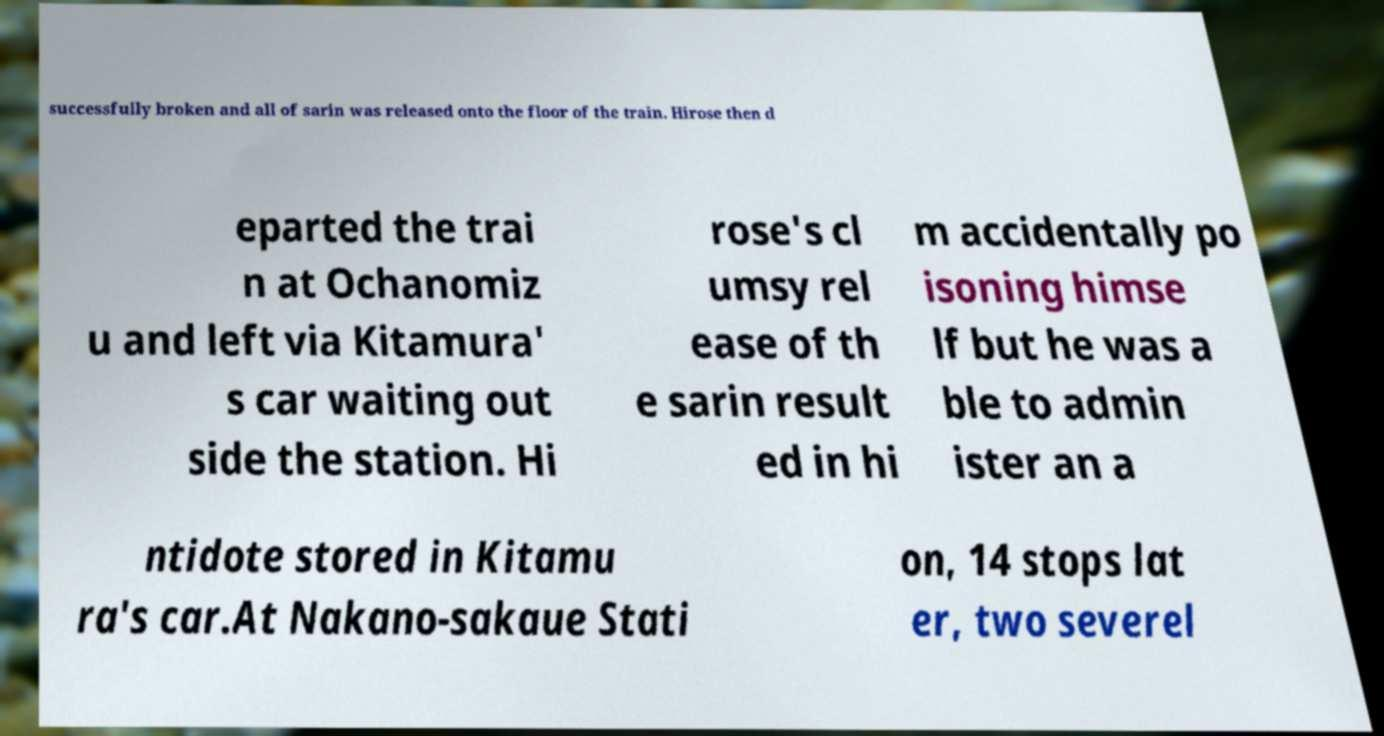I need the written content from this picture converted into text. Can you do that? successfully broken and all of sarin was released onto the floor of the train. Hirose then d eparted the trai n at Ochanomiz u and left via Kitamura' s car waiting out side the station. Hi rose's cl umsy rel ease of th e sarin result ed in hi m accidentally po isoning himse lf but he was a ble to admin ister an a ntidote stored in Kitamu ra's car.At Nakano-sakaue Stati on, 14 stops lat er, two severel 